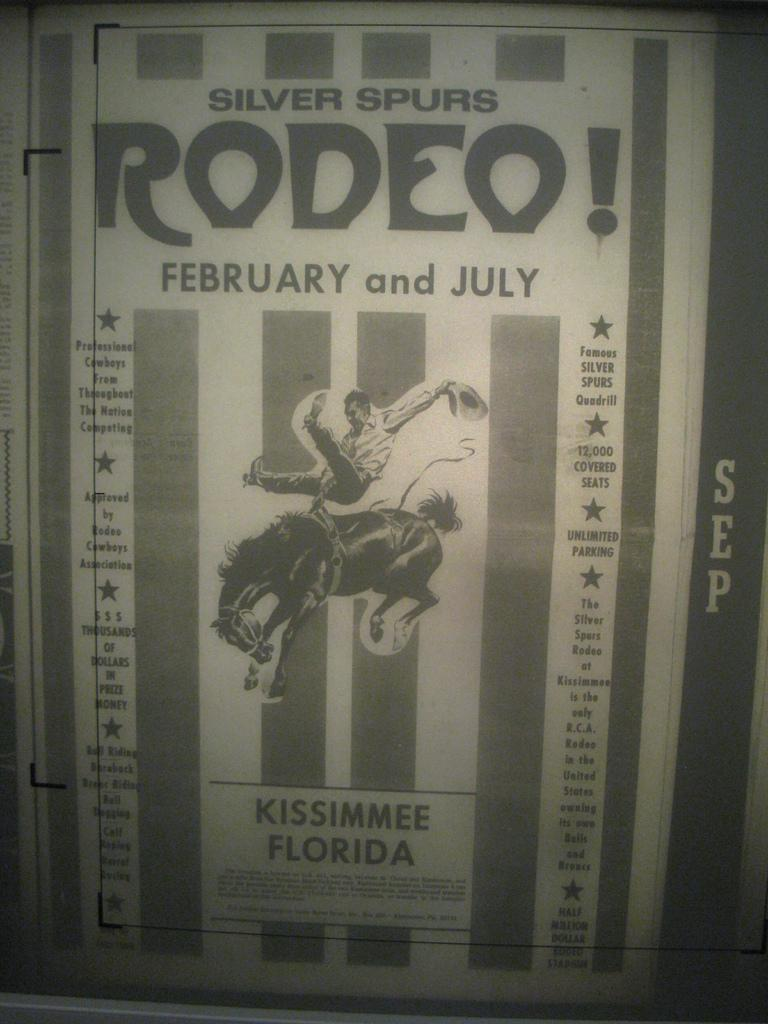<image>
Relay a brief, clear account of the picture shown. A monochrome rodeo poster advertises an event in Florida. 